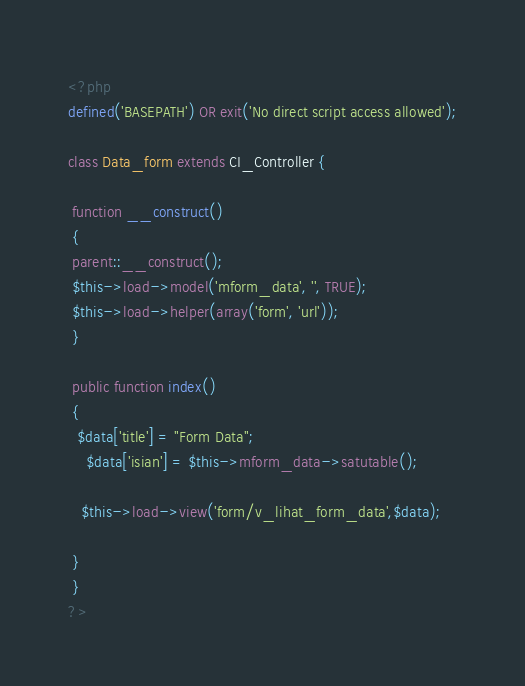<code> <loc_0><loc_0><loc_500><loc_500><_PHP_><?php
defined('BASEPATH') OR exit('No direct script access allowed');

class Data_form extends CI_Controller {

 function __construct()
 {
 parent::__construct();
 $this->load->model('mform_data', '', TRUE);
 $this->load->helper(array('form', 'url'));
 }

 public function index()
 {
  $data['title'] = "Form Data"; 
    $data['isian'] = $this->mform_data->satutable();   
 
   $this->load->view('form/v_lihat_form_data',$data);
  
 } 
 }
?></code> 